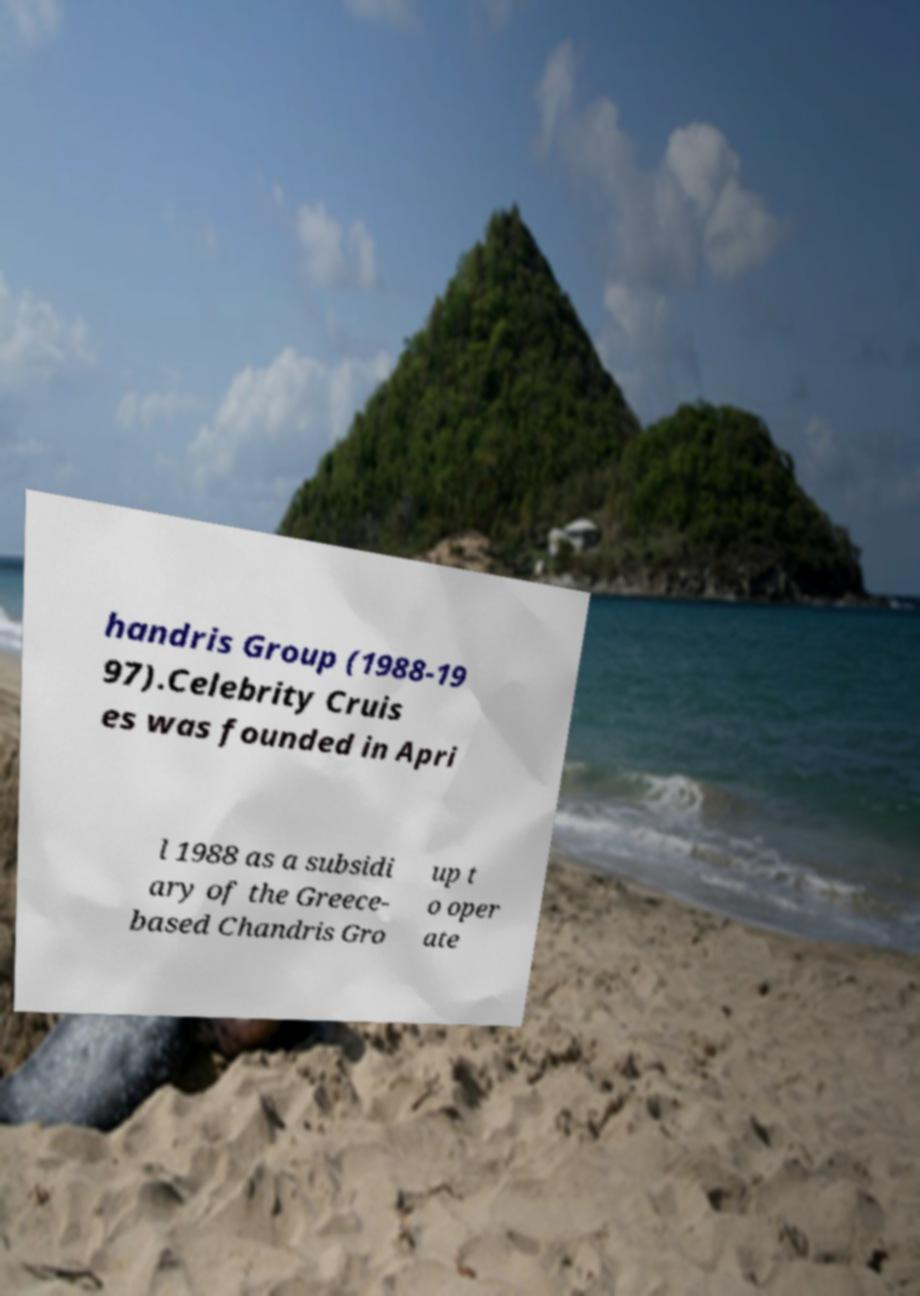Please read and relay the text visible in this image. What does it say? handris Group (1988-19 97).Celebrity Cruis es was founded in Apri l 1988 as a subsidi ary of the Greece- based Chandris Gro up t o oper ate 